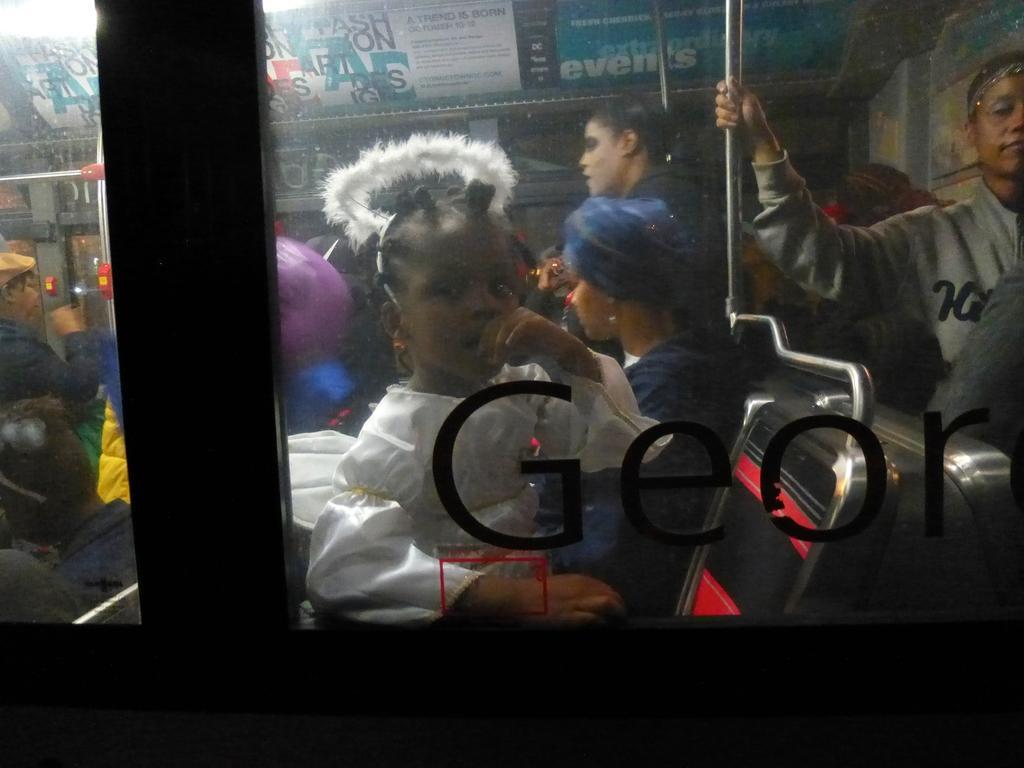Please provide a concise description of this image. In this picture we can see text on glass, through this glass we can see people, rods and boards. 